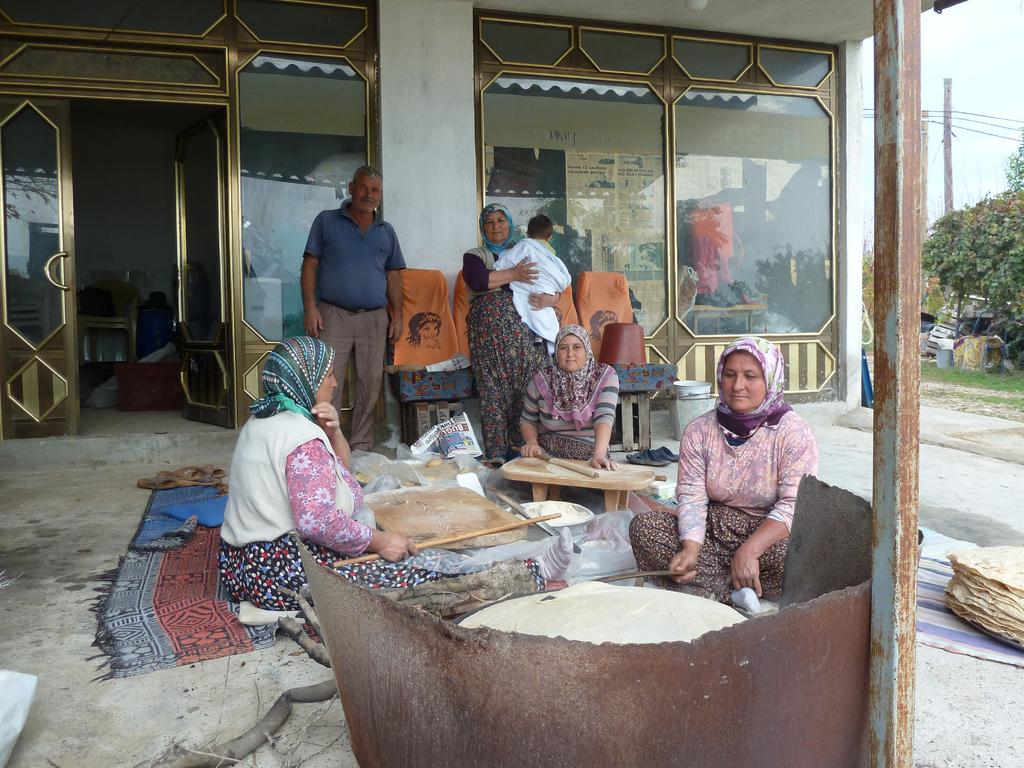How many people are sitting in the image? There are three people sitting in the image. What are the people sitting doing? The people are doing Roti. How many people are standing in the image? There are two people standing in the image. What type of vegetation can be seen in the image? There are trees and grass in the image. What man-made structure is present in the image? There is an electric pole in the image. What architectural feature can be seen on the left side of the image? There is an open door on the left side of the image. What type of paste is being used by the people in the image? There is no mention of paste being used in the image; the people are doing Roti. How many boots are visible in the image? There are no boots visible in the image. 